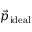Convert formula to latex. <formula><loc_0><loc_0><loc_500><loc_500>\vec { p } _ { i d e a l }</formula> 